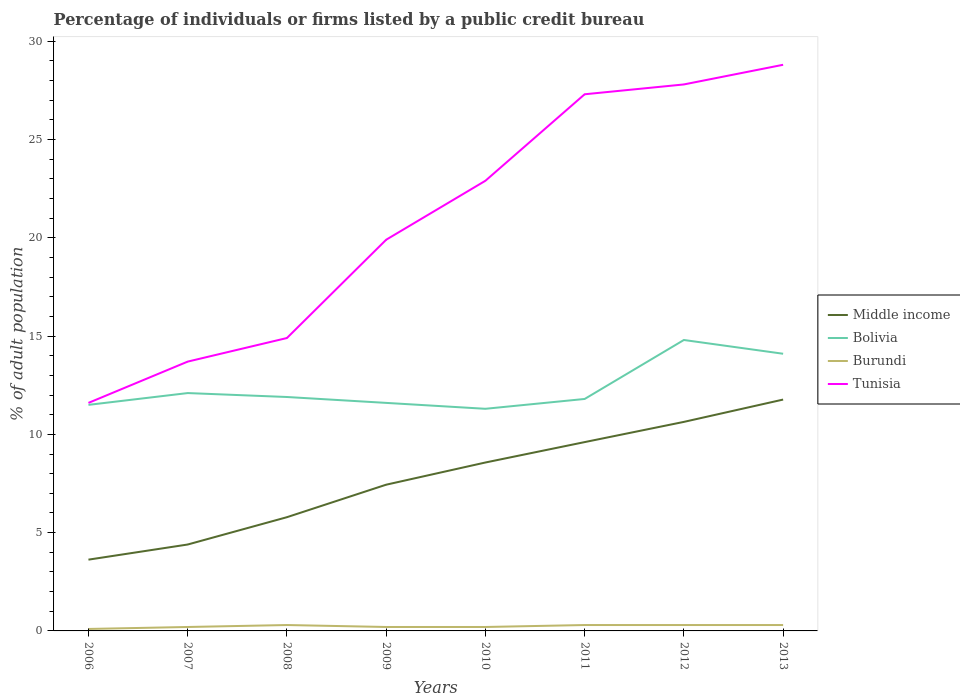How many different coloured lines are there?
Your answer should be very brief. 4. Is the number of lines equal to the number of legend labels?
Your response must be concise. Yes. Across all years, what is the maximum percentage of population listed by a public credit bureau in Middle income?
Offer a very short reply. 3.63. What is the total percentage of population listed by a public credit bureau in Tunisia in the graph?
Your answer should be compact. -16.2. What is the difference between the highest and the second highest percentage of population listed by a public credit bureau in Tunisia?
Your answer should be compact. 17.2. How many lines are there?
Your answer should be compact. 4. What is the difference between two consecutive major ticks on the Y-axis?
Keep it short and to the point. 5. What is the title of the graph?
Your answer should be very brief. Percentage of individuals or firms listed by a public credit bureau. What is the label or title of the X-axis?
Ensure brevity in your answer.  Years. What is the label or title of the Y-axis?
Provide a succinct answer. % of adult population. What is the % of adult population of Middle income in 2006?
Your answer should be very brief. 3.63. What is the % of adult population of Bolivia in 2006?
Give a very brief answer. 11.5. What is the % of adult population in Burundi in 2006?
Offer a terse response. 0.1. What is the % of adult population in Tunisia in 2006?
Your answer should be very brief. 11.6. What is the % of adult population of Middle income in 2007?
Offer a terse response. 4.4. What is the % of adult population in Middle income in 2008?
Make the answer very short. 5.79. What is the % of adult population in Bolivia in 2008?
Provide a short and direct response. 11.9. What is the % of adult population of Middle income in 2009?
Your answer should be compact. 7.44. What is the % of adult population in Bolivia in 2009?
Your answer should be compact. 11.6. What is the % of adult population of Middle income in 2010?
Your response must be concise. 8.57. What is the % of adult population of Tunisia in 2010?
Offer a very short reply. 22.9. What is the % of adult population in Middle income in 2011?
Give a very brief answer. 9.61. What is the % of adult population in Burundi in 2011?
Offer a very short reply. 0.3. What is the % of adult population in Tunisia in 2011?
Provide a short and direct response. 27.3. What is the % of adult population in Middle income in 2012?
Keep it short and to the point. 10.63. What is the % of adult population in Bolivia in 2012?
Ensure brevity in your answer.  14.8. What is the % of adult population of Tunisia in 2012?
Offer a terse response. 27.8. What is the % of adult population of Middle income in 2013?
Keep it short and to the point. 11.77. What is the % of adult population of Bolivia in 2013?
Provide a short and direct response. 14.1. What is the % of adult population in Burundi in 2013?
Make the answer very short. 0.3. What is the % of adult population in Tunisia in 2013?
Offer a very short reply. 28.8. Across all years, what is the maximum % of adult population of Middle income?
Make the answer very short. 11.77. Across all years, what is the maximum % of adult population of Bolivia?
Ensure brevity in your answer.  14.8. Across all years, what is the maximum % of adult population in Burundi?
Your response must be concise. 0.3. Across all years, what is the maximum % of adult population in Tunisia?
Your response must be concise. 28.8. Across all years, what is the minimum % of adult population of Middle income?
Offer a very short reply. 3.63. Across all years, what is the minimum % of adult population in Tunisia?
Give a very brief answer. 11.6. What is the total % of adult population in Middle income in the graph?
Make the answer very short. 61.82. What is the total % of adult population in Bolivia in the graph?
Your response must be concise. 99.1. What is the total % of adult population of Tunisia in the graph?
Your response must be concise. 166.9. What is the difference between the % of adult population in Middle income in 2006 and that in 2007?
Make the answer very short. -0.77. What is the difference between the % of adult population of Bolivia in 2006 and that in 2007?
Your response must be concise. -0.6. What is the difference between the % of adult population in Burundi in 2006 and that in 2007?
Keep it short and to the point. -0.1. What is the difference between the % of adult population in Tunisia in 2006 and that in 2007?
Your answer should be very brief. -2.1. What is the difference between the % of adult population of Middle income in 2006 and that in 2008?
Your answer should be compact. -2.16. What is the difference between the % of adult population in Middle income in 2006 and that in 2009?
Ensure brevity in your answer.  -3.81. What is the difference between the % of adult population in Bolivia in 2006 and that in 2009?
Make the answer very short. -0.1. What is the difference between the % of adult population of Tunisia in 2006 and that in 2009?
Keep it short and to the point. -8.3. What is the difference between the % of adult population in Middle income in 2006 and that in 2010?
Make the answer very short. -4.94. What is the difference between the % of adult population in Bolivia in 2006 and that in 2010?
Offer a very short reply. 0.2. What is the difference between the % of adult population of Burundi in 2006 and that in 2010?
Provide a short and direct response. -0.1. What is the difference between the % of adult population of Middle income in 2006 and that in 2011?
Provide a succinct answer. -5.98. What is the difference between the % of adult population in Bolivia in 2006 and that in 2011?
Offer a terse response. -0.3. What is the difference between the % of adult population in Tunisia in 2006 and that in 2011?
Give a very brief answer. -15.7. What is the difference between the % of adult population of Middle income in 2006 and that in 2012?
Make the answer very short. -7.01. What is the difference between the % of adult population of Bolivia in 2006 and that in 2012?
Provide a short and direct response. -3.3. What is the difference between the % of adult population of Tunisia in 2006 and that in 2012?
Keep it short and to the point. -16.2. What is the difference between the % of adult population in Middle income in 2006 and that in 2013?
Your answer should be very brief. -8.14. What is the difference between the % of adult population in Burundi in 2006 and that in 2013?
Your response must be concise. -0.2. What is the difference between the % of adult population of Tunisia in 2006 and that in 2013?
Your answer should be very brief. -17.2. What is the difference between the % of adult population in Middle income in 2007 and that in 2008?
Your response must be concise. -1.39. What is the difference between the % of adult population of Burundi in 2007 and that in 2008?
Your answer should be compact. -0.1. What is the difference between the % of adult population of Middle income in 2007 and that in 2009?
Offer a terse response. -3.04. What is the difference between the % of adult population in Burundi in 2007 and that in 2009?
Your response must be concise. 0. What is the difference between the % of adult population of Tunisia in 2007 and that in 2009?
Ensure brevity in your answer.  -6.2. What is the difference between the % of adult population of Middle income in 2007 and that in 2010?
Your answer should be compact. -4.17. What is the difference between the % of adult population in Burundi in 2007 and that in 2010?
Your response must be concise. 0. What is the difference between the % of adult population in Tunisia in 2007 and that in 2010?
Give a very brief answer. -9.2. What is the difference between the % of adult population of Middle income in 2007 and that in 2011?
Provide a succinct answer. -5.21. What is the difference between the % of adult population in Burundi in 2007 and that in 2011?
Your response must be concise. -0.1. What is the difference between the % of adult population of Middle income in 2007 and that in 2012?
Ensure brevity in your answer.  -6.24. What is the difference between the % of adult population of Burundi in 2007 and that in 2012?
Your answer should be very brief. -0.1. What is the difference between the % of adult population of Tunisia in 2007 and that in 2012?
Provide a short and direct response. -14.1. What is the difference between the % of adult population in Middle income in 2007 and that in 2013?
Offer a very short reply. -7.37. What is the difference between the % of adult population of Tunisia in 2007 and that in 2013?
Offer a terse response. -15.1. What is the difference between the % of adult population in Middle income in 2008 and that in 2009?
Ensure brevity in your answer.  -1.65. What is the difference between the % of adult population of Middle income in 2008 and that in 2010?
Give a very brief answer. -2.78. What is the difference between the % of adult population in Bolivia in 2008 and that in 2010?
Your response must be concise. 0.6. What is the difference between the % of adult population in Burundi in 2008 and that in 2010?
Keep it short and to the point. 0.1. What is the difference between the % of adult population of Middle income in 2008 and that in 2011?
Offer a terse response. -3.82. What is the difference between the % of adult population of Burundi in 2008 and that in 2011?
Ensure brevity in your answer.  0. What is the difference between the % of adult population of Tunisia in 2008 and that in 2011?
Your answer should be very brief. -12.4. What is the difference between the % of adult population in Middle income in 2008 and that in 2012?
Your answer should be compact. -4.85. What is the difference between the % of adult population in Burundi in 2008 and that in 2012?
Your answer should be compact. 0. What is the difference between the % of adult population in Middle income in 2008 and that in 2013?
Your answer should be compact. -5.98. What is the difference between the % of adult population of Tunisia in 2008 and that in 2013?
Offer a very short reply. -13.9. What is the difference between the % of adult population in Middle income in 2009 and that in 2010?
Keep it short and to the point. -1.13. What is the difference between the % of adult population in Tunisia in 2009 and that in 2010?
Provide a succinct answer. -3. What is the difference between the % of adult population in Middle income in 2009 and that in 2011?
Make the answer very short. -2.17. What is the difference between the % of adult population of Tunisia in 2009 and that in 2011?
Give a very brief answer. -7.4. What is the difference between the % of adult population in Middle income in 2009 and that in 2012?
Your response must be concise. -3.19. What is the difference between the % of adult population in Middle income in 2009 and that in 2013?
Your answer should be very brief. -4.33. What is the difference between the % of adult population of Middle income in 2010 and that in 2011?
Offer a very short reply. -1.04. What is the difference between the % of adult population of Tunisia in 2010 and that in 2011?
Keep it short and to the point. -4.4. What is the difference between the % of adult population of Middle income in 2010 and that in 2012?
Your response must be concise. -2.07. What is the difference between the % of adult population of Bolivia in 2010 and that in 2012?
Your answer should be very brief. -3.5. What is the difference between the % of adult population of Burundi in 2010 and that in 2012?
Your response must be concise. -0.1. What is the difference between the % of adult population in Tunisia in 2010 and that in 2012?
Your answer should be compact. -4.9. What is the difference between the % of adult population in Middle income in 2010 and that in 2013?
Offer a very short reply. -3.2. What is the difference between the % of adult population of Bolivia in 2010 and that in 2013?
Provide a succinct answer. -2.8. What is the difference between the % of adult population of Middle income in 2011 and that in 2012?
Give a very brief answer. -1.03. What is the difference between the % of adult population of Burundi in 2011 and that in 2012?
Offer a very short reply. 0. What is the difference between the % of adult population in Tunisia in 2011 and that in 2012?
Your answer should be compact. -0.5. What is the difference between the % of adult population in Middle income in 2011 and that in 2013?
Make the answer very short. -2.16. What is the difference between the % of adult population in Bolivia in 2011 and that in 2013?
Offer a very short reply. -2.3. What is the difference between the % of adult population of Burundi in 2011 and that in 2013?
Provide a short and direct response. 0. What is the difference between the % of adult population of Tunisia in 2011 and that in 2013?
Offer a very short reply. -1.5. What is the difference between the % of adult population of Middle income in 2012 and that in 2013?
Your response must be concise. -1.14. What is the difference between the % of adult population in Tunisia in 2012 and that in 2013?
Your answer should be compact. -1. What is the difference between the % of adult population of Middle income in 2006 and the % of adult population of Bolivia in 2007?
Make the answer very short. -8.47. What is the difference between the % of adult population in Middle income in 2006 and the % of adult population in Burundi in 2007?
Give a very brief answer. 3.43. What is the difference between the % of adult population of Middle income in 2006 and the % of adult population of Tunisia in 2007?
Give a very brief answer. -10.07. What is the difference between the % of adult population of Bolivia in 2006 and the % of adult population of Tunisia in 2007?
Provide a short and direct response. -2.2. What is the difference between the % of adult population in Burundi in 2006 and the % of adult population in Tunisia in 2007?
Make the answer very short. -13.6. What is the difference between the % of adult population in Middle income in 2006 and the % of adult population in Bolivia in 2008?
Offer a terse response. -8.27. What is the difference between the % of adult population in Middle income in 2006 and the % of adult population in Burundi in 2008?
Your answer should be compact. 3.33. What is the difference between the % of adult population in Middle income in 2006 and the % of adult population in Tunisia in 2008?
Provide a succinct answer. -11.27. What is the difference between the % of adult population in Bolivia in 2006 and the % of adult population in Burundi in 2008?
Your answer should be very brief. 11.2. What is the difference between the % of adult population of Bolivia in 2006 and the % of adult population of Tunisia in 2008?
Give a very brief answer. -3.4. What is the difference between the % of adult population in Burundi in 2006 and the % of adult population in Tunisia in 2008?
Keep it short and to the point. -14.8. What is the difference between the % of adult population of Middle income in 2006 and the % of adult population of Bolivia in 2009?
Your answer should be compact. -7.97. What is the difference between the % of adult population in Middle income in 2006 and the % of adult population in Burundi in 2009?
Ensure brevity in your answer.  3.43. What is the difference between the % of adult population of Middle income in 2006 and the % of adult population of Tunisia in 2009?
Provide a succinct answer. -16.27. What is the difference between the % of adult population in Bolivia in 2006 and the % of adult population in Tunisia in 2009?
Provide a succinct answer. -8.4. What is the difference between the % of adult population in Burundi in 2006 and the % of adult population in Tunisia in 2009?
Offer a terse response. -19.8. What is the difference between the % of adult population in Middle income in 2006 and the % of adult population in Bolivia in 2010?
Make the answer very short. -7.67. What is the difference between the % of adult population of Middle income in 2006 and the % of adult population of Burundi in 2010?
Your answer should be compact. 3.43. What is the difference between the % of adult population of Middle income in 2006 and the % of adult population of Tunisia in 2010?
Ensure brevity in your answer.  -19.27. What is the difference between the % of adult population of Bolivia in 2006 and the % of adult population of Tunisia in 2010?
Make the answer very short. -11.4. What is the difference between the % of adult population of Burundi in 2006 and the % of adult population of Tunisia in 2010?
Give a very brief answer. -22.8. What is the difference between the % of adult population of Middle income in 2006 and the % of adult population of Bolivia in 2011?
Make the answer very short. -8.17. What is the difference between the % of adult population in Middle income in 2006 and the % of adult population in Burundi in 2011?
Offer a very short reply. 3.33. What is the difference between the % of adult population in Middle income in 2006 and the % of adult population in Tunisia in 2011?
Your response must be concise. -23.67. What is the difference between the % of adult population in Bolivia in 2006 and the % of adult population in Burundi in 2011?
Make the answer very short. 11.2. What is the difference between the % of adult population of Bolivia in 2006 and the % of adult population of Tunisia in 2011?
Your answer should be compact. -15.8. What is the difference between the % of adult population of Burundi in 2006 and the % of adult population of Tunisia in 2011?
Your answer should be compact. -27.2. What is the difference between the % of adult population of Middle income in 2006 and the % of adult population of Bolivia in 2012?
Keep it short and to the point. -11.17. What is the difference between the % of adult population of Middle income in 2006 and the % of adult population of Burundi in 2012?
Give a very brief answer. 3.33. What is the difference between the % of adult population in Middle income in 2006 and the % of adult population in Tunisia in 2012?
Make the answer very short. -24.17. What is the difference between the % of adult population in Bolivia in 2006 and the % of adult population in Tunisia in 2012?
Your response must be concise. -16.3. What is the difference between the % of adult population of Burundi in 2006 and the % of adult population of Tunisia in 2012?
Provide a short and direct response. -27.7. What is the difference between the % of adult population in Middle income in 2006 and the % of adult population in Bolivia in 2013?
Provide a short and direct response. -10.47. What is the difference between the % of adult population in Middle income in 2006 and the % of adult population in Burundi in 2013?
Offer a terse response. 3.33. What is the difference between the % of adult population in Middle income in 2006 and the % of adult population in Tunisia in 2013?
Give a very brief answer. -25.17. What is the difference between the % of adult population in Bolivia in 2006 and the % of adult population in Burundi in 2013?
Offer a very short reply. 11.2. What is the difference between the % of adult population in Bolivia in 2006 and the % of adult population in Tunisia in 2013?
Make the answer very short. -17.3. What is the difference between the % of adult population in Burundi in 2006 and the % of adult population in Tunisia in 2013?
Ensure brevity in your answer.  -28.7. What is the difference between the % of adult population of Middle income in 2007 and the % of adult population of Bolivia in 2008?
Your answer should be very brief. -7.5. What is the difference between the % of adult population in Middle income in 2007 and the % of adult population in Burundi in 2008?
Provide a succinct answer. 4.1. What is the difference between the % of adult population in Middle income in 2007 and the % of adult population in Tunisia in 2008?
Keep it short and to the point. -10.5. What is the difference between the % of adult population in Bolivia in 2007 and the % of adult population in Burundi in 2008?
Provide a short and direct response. 11.8. What is the difference between the % of adult population in Bolivia in 2007 and the % of adult population in Tunisia in 2008?
Provide a short and direct response. -2.8. What is the difference between the % of adult population of Burundi in 2007 and the % of adult population of Tunisia in 2008?
Offer a very short reply. -14.7. What is the difference between the % of adult population of Middle income in 2007 and the % of adult population of Bolivia in 2009?
Keep it short and to the point. -7.2. What is the difference between the % of adult population in Middle income in 2007 and the % of adult population in Burundi in 2009?
Your response must be concise. 4.2. What is the difference between the % of adult population in Middle income in 2007 and the % of adult population in Tunisia in 2009?
Ensure brevity in your answer.  -15.5. What is the difference between the % of adult population of Bolivia in 2007 and the % of adult population of Burundi in 2009?
Make the answer very short. 11.9. What is the difference between the % of adult population in Burundi in 2007 and the % of adult population in Tunisia in 2009?
Make the answer very short. -19.7. What is the difference between the % of adult population of Middle income in 2007 and the % of adult population of Bolivia in 2010?
Give a very brief answer. -6.9. What is the difference between the % of adult population in Middle income in 2007 and the % of adult population in Burundi in 2010?
Provide a succinct answer. 4.2. What is the difference between the % of adult population in Middle income in 2007 and the % of adult population in Tunisia in 2010?
Make the answer very short. -18.5. What is the difference between the % of adult population in Bolivia in 2007 and the % of adult population in Tunisia in 2010?
Offer a very short reply. -10.8. What is the difference between the % of adult population of Burundi in 2007 and the % of adult population of Tunisia in 2010?
Keep it short and to the point. -22.7. What is the difference between the % of adult population in Middle income in 2007 and the % of adult population in Bolivia in 2011?
Your answer should be compact. -7.4. What is the difference between the % of adult population of Middle income in 2007 and the % of adult population of Burundi in 2011?
Your answer should be very brief. 4.1. What is the difference between the % of adult population of Middle income in 2007 and the % of adult population of Tunisia in 2011?
Your response must be concise. -22.9. What is the difference between the % of adult population of Bolivia in 2007 and the % of adult population of Burundi in 2011?
Your response must be concise. 11.8. What is the difference between the % of adult population in Bolivia in 2007 and the % of adult population in Tunisia in 2011?
Provide a succinct answer. -15.2. What is the difference between the % of adult population of Burundi in 2007 and the % of adult population of Tunisia in 2011?
Offer a very short reply. -27.1. What is the difference between the % of adult population of Middle income in 2007 and the % of adult population of Bolivia in 2012?
Your answer should be very brief. -10.4. What is the difference between the % of adult population in Middle income in 2007 and the % of adult population in Burundi in 2012?
Ensure brevity in your answer.  4.1. What is the difference between the % of adult population of Middle income in 2007 and the % of adult population of Tunisia in 2012?
Make the answer very short. -23.4. What is the difference between the % of adult population of Bolivia in 2007 and the % of adult population of Burundi in 2012?
Your answer should be compact. 11.8. What is the difference between the % of adult population of Bolivia in 2007 and the % of adult population of Tunisia in 2012?
Offer a very short reply. -15.7. What is the difference between the % of adult population in Burundi in 2007 and the % of adult population in Tunisia in 2012?
Provide a short and direct response. -27.6. What is the difference between the % of adult population in Middle income in 2007 and the % of adult population in Bolivia in 2013?
Offer a terse response. -9.7. What is the difference between the % of adult population in Middle income in 2007 and the % of adult population in Burundi in 2013?
Provide a succinct answer. 4.1. What is the difference between the % of adult population in Middle income in 2007 and the % of adult population in Tunisia in 2013?
Keep it short and to the point. -24.4. What is the difference between the % of adult population of Bolivia in 2007 and the % of adult population of Burundi in 2013?
Your answer should be compact. 11.8. What is the difference between the % of adult population of Bolivia in 2007 and the % of adult population of Tunisia in 2013?
Keep it short and to the point. -16.7. What is the difference between the % of adult population of Burundi in 2007 and the % of adult population of Tunisia in 2013?
Give a very brief answer. -28.6. What is the difference between the % of adult population in Middle income in 2008 and the % of adult population in Bolivia in 2009?
Make the answer very short. -5.81. What is the difference between the % of adult population of Middle income in 2008 and the % of adult population of Burundi in 2009?
Offer a terse response. 5.59. What is the difference between the % of adult population in Middle income in 2008 and the % of adult population in Tunisia in 2009?
Ensure brevity in your answer.  -14.11. What is the difference between the % of adult population of Burundi in 2008 and the % of adult population of Tunisia in 2009?
Your answer should be very brief. -19.6. What is the difference between the % of adult population in Middle income in 2008 and the % of adult population in Bolivia in 2010?
Provide a succinct answer. -5.51. What is the difference between the % of adult population in Middle income in 2008 and the % of adult population in Burundi in 2010?
Ensure brevity in your answer.  5.59. What is the difference between the % of adult population of Middle income in 2008 and the % of adult population of Tunisia in 2010?
Your answer should be very brief. -17.11. What is the difference between the % of adult population in Bolivia in 2008 and the % of adult population in Burundi in 2010?
Provide a short and direct response. 11.7. What is the difference between the % of adult population of Burundi in 2008 and the % of adult population of Tunisia in 2010?
Offer a terse response. -22.6. What is the difference between the % of adult population in Middle income in 2008 and the % of adult population in Bolivia in 2011?
Your response must be concise. -6.01. What is the difference between the % of adult population in Middle income in 2008 and the % of adult population in Burundi in 2011?
Keep it short and to the point. 5.49. What is the difference between the % of adult population of Middle income in 2008 and the % of adult population of Tunisia in 2011?
Keep it short and to the point. -21.51. What is the difference between the % of adult population of Bolivia in 2008 and the % of adult population of Tunisia in 2011?
Provide a succinct answer. -15.4. What is the difference between the % of adult population of Burundi in 2008 and the % of adult population of Tunisia in 2011?
Give a very brief answer. -27. What is the difference between the % of adult population in Middle income in 2008 and the % of adult population in Bolivia in 2012?
Ensure brevity in your answer.  -9.01. What is the difference between the % of adult population of Middle income in 2008 and the % of adult population of Burundi in 2012?
Provide a succinct answer. 5.49. What is the difference between the % of adult population of Middle income in 2008 and the % of adult population of Tunisia in 2012?
Offer a terse response. -22.01. What is the difference between the % of adult population of Bolivia in 2008 and the % of adult population of Burundi in 2012?
Provide a succinct answer. 11.6. What is the difference between the % of adult population of Bolivia in 2008 and the % of adult population of Tunisia in 2012?
Your response must be concise. -15.9. What is the difference between the % of adult population in Burundi in 2008 and the % of adult population in Tunisia in 2012?
Offer a very short reply. -27.5. What is the difference between the % of adult population in Middle income in 2008 and the % of adult population in Bolivia in 2013?
Provide a short and direct response. -8.31. What is the difference between the % of adult population of Middle income in 2008 and the % of adult population of Burundi in 2013?
Provide a succinct answer. 5.49. What is the difference between the % of adult population in Middle income in 2008 and the % of adult population in Tunisia in 2013?
Provide a succinct answer. -23.01. What is the difference between the % of adult population in Bolivia in 2008 and the % of adult population in Burundi in 2013?
Make the answer very short. 11.6. What is the difference between the % of adult population in Bolivia in 2008 and the % of adult population in Tunisia in 2013?
Provide a short and direct response. -16.9. What is the difference between the % of adult population in Burundi in 2008 and the % of adult population in Tunisia in 2013?
Offer a terse response. -28.5. What is the difference between the % of adult population of Middle income in 2009 and the % of adult population of Bolivia in 2010?
Give a very brief answer. -3.86. What is the difference between the % of adult population of Middle income in 2009 and the % of adult population of Burundi in 2010?
Make the answer very short. 7.24. What is the difference between the % of adult population of Middle income in 2009 and the % of adult population of Tunisia in 2010?
Ensure brevity in your answer.  -15.46. What is the difference between the % of adult population of Burundi in 2009 and the % of adult population of Tunisia in 2010?
Offer a very short reply. -22.7. What is the difference between the % of adult population of Middle income in 2009 and the % of adult population of Bolivia in 2011?
Provide a succinct answer. -4.36. What is the difference between the % of adult population of Middle income in 2009 and the % of adult population of Burundi in 2011?
Ensure brevity in your answer.  7.14. What is the difference between the % of adult population in Middle income in 2009 and the % of adult population in Tunisia in 2011?
Make the answer very short. -19.86. What is the difference between the % of adult population of Bolivia in 2009 and the % of adult population of Burundi in 2011?
Provide a succinct answer. 11.3. What is the difference between the % of adult population in Bolivia in 2009 and the % of adult population in Tunisia in 2011?
Give a very brief answer. -15.7. What is the difference between the % of adult population in Burundi in 2009 and the % of adult population in Tunisia in 2011?
Offer a terse response. -27.1. What is the difference between the % of adult population in Middle income in 2009 and the % of adult population in Bolivia in 2012?
Provide a short and direct response. -7.36. What is the difference between the % of adult population in Middle income in 2009 and the % of adult population in Burundi in 2012?
Give a very brief answer. 7.14. What is the difference between the % of adult population in Middle income in 2009 and the % of adult population in Tunisia in 2012?
Keep it short and to the point. -20.36. What is the difference between the % of adult population of Bolivia in 2009 and the % of adult population of Burundi in 2012?
Keep it short and to the point. 11.3. What is the difference between the % of adult population of Bolivia in 2009 and the % of adult population of Tunisia in 2012?
Make the answer very short. -16.2. What is the difference between the % of adult population in Burundi in 2009 and the % of adult population in Tunisia in 2012?
Your answer should be very brief. -27.6. What is the difference between the % of adult population of Middle income in 2009 and the % of adult population of Bolivia in 2013?
Give a very brief answer. -6.66. What is the difference between the % of adult population of Middle income in 2009 and the % of adult population of Burundi in 2013?
Offer a very short reply. 7.14. What is the difference between the % of adult population in Middle income in 2009 and the % of adult population in Tunisia in 2013?
Your answer should be compact. -21.36. What is the difference between the % of adult population in Bolivia in 2009 and the % of adult population in Tunisia in 2013?
Keep it short and to the point. -17.2. What is the difference between the % of adult population of Burundi in 2009 and the % of adult population of Tunisia in 2013?
Offer a terse response. -28.6. What is the difference between the % of adult population of Middle income in 2010 and the % of adult population of Bolivia in 2011?
Ensure brevity in your answer.  -3.23. What is the difference between the % of adult population of Middle income in 2010 and the % of adult population of Burundi in 2011?
Offer a very short reply. 8.27. What is the difference between the % of adult population of Middle income in 2010 and the % of adult population of Tunisia in 2011?
Provide a succinct answer. -18.73. What is the difference between the % of adult population of Bolivia in 2010 and the % of adult population of Tunisia in 2011?
Offer a very short reply. -16. What is the difference between the % of adult population of Burundi in 2010 and the % of adult population of Tunisia in 2011?
Your answer should be compact. -27.1. What is the difference between the % of adult population of Middle income in 2010 and the % of adult population of Bolivia in 2012?
Provide a short and direct response. -6.23. What is the difference between the % of adult population of Middle income in 2010 and the % of adult population of Burundi in 2012?
Ensure brevity in your answer.  8.27. What is the difference between the % of adult population in Middle income in 2010 and the % of adult population in Tunisia in 2012?
Ensure brevity in your answer.  -19.23. What is the difference between the % of adult population of Bolivia in 2010 and the % of adult population of Burundi in 2012?
Offer a very short reply. 11. What is the difference between the % of adult population of Bolivia in 2010 and the % of adult population of Tunisia in 2012?
Offer a terse response. -16.5. What is the difference between the % of adult population in Burundi in 2010 and the % of adult population in Tunisia in 2012?
Make the answer very short. -27.6. What is the difference between the % of adult population of Middle income in 2010 and the % of adult population of Bolivia in 2013?
Ensure brevity in your answer.  -5.53. What is the difference between the % of adult population of Middle income in 2010 and the % of adult population of Burundi in 2013?
Offer a very short reply. 8.27. What is the difference between the % of adult population in Middle income in 2010 and the % of adult population in Tunisia in 2013?
Give a very brief answer. -20.23. What is the difference between the % of adult population in Bolivia in 2010 and the % of adult population in Tunisia in 2013?
Your answer should be very brief. -17.5. What is the difference between the % of adult population of Burundi in 2010 and the % of adult population of Tunisia in 2013?
Offer a terse response. -28.6. What is the difference between the % of adult population in Middle income in 2011 and the % of adult population in Bolivia in 2012?
Give a very brief answer. -5.19. What is the difference between the % of adult population in Middle income in 2011 and the % of adult population in Burundi in 2012?
Offer a terse response. 9.31. What is the difference between the % of adult population of Middle income in 2011 and the % of adult population of Tunisia in 2012?
Give a very brief answer. -18.19. What is the difference between the % of adult population in Bolivia in 2011 and the % of adult population in Tunisia in 2012?
Make the answer very short. -16. What is the difference between the % of adult population in Burundi in 2011 and the % of adult population in Tunisia in 2012?
Provide a succinct answer. -27.5. What is the difference between the % of adult population of Middle income in 2011 and the % of adult population of Bolivia in 2013?
Your answer should be very brief. -4.49. What is the difference between the % of adult population in Middle income in 2011 and the % of adult population in Burundi in 2013?
Ensure brevity in your answer.  9.31. What is the difference between the % of adult population in Middle income in 2011 and the % of adult population in Tunisia in 2013?
Ensure brevity in your answer.  -19.19. What is the difference between the % of adult population of Burundi in 2011 and the % of adult population of Tunisia in 2013?
Your response must be concise. -28.5. What is the difference between the % of adult population in Middle income in 2012 and the % of adult population in Bolivia in 2013?
Offer a terse response. -3.47. What is the difference between the % of adult population of Middle income in 2012 and the % of adult population of Burundi in 2013?
Ensure brevity in your answer.  10.33. What is the difference between the % of adult population of Middle income in 2012 and the % of adult population of Tunisia in 2013?
Give a very brief answer. -18.17. What is the difference between the % of adult population in Bolivia in 2012 and the % of adult population in Burundi in 2013?
Your response must be concise. 14.5. What is the difference between the % of adult population of Bolivia in 2012 and the % of adult population of Tunisia in 2013?
Your answer should be compact. -14. What is the difference between the % of adult population of Burundi in 2012 and the % of adult population of Tunisia in 2013?
Give a very brief answer. -28.5. What is the average % of adult population in Middle income per year?
Give a very brief answer. 7.73. What is the average % of adult population of Bolivia per year?
Give a very brief answer. 12.39. What is the average % of adult population of Burundi per year?
Offer a terse response. 0.24. What is the average % of adult population in Tunisia per year?
Your answer should be compact. 20.86. In the year 2006, what is the difference between the % of adult population of Middle income and % of adult population of Bolivia?
Offer a terse response. -7.87. In the year 2006, what is the difference between the % of adult population of Middle income and % of adult population of Burundi?
Offer a terse response. 3.53. In the year 2006, what is the difference between the % of adult population in Middle income and % of adult population in Tunisia?
Ensure brevity in your answer.  -7.97. In the year 2006, what is the difference between the % of adult population of Bolivia and % of adult population of Burundi?
Offer a very short reply. 11.4. In the year 2006, what is the difference between the % of adult population in Bolivia and % of adult population in Tunisia?
Offer a terse response. -0.1. In the year 2007, what is the difference between the % of adult population in Middle income and % of adult population in Bolivia?
Provide a short and direct response. -7.7. In the year 2007, what is the difference between the % of adult population of Middle income and % of adult population of Burundi?
Keep it short and to the point. 4.2. In the year 2007, what is the difference between the % of adult population in Middle income and % of adult population in Tunisia?
Ensure brevity in your answer.  -9.3. In the year 2007, what is the difference between the % of adult population in Bolivia and % of adult population in Burundi?
Your answer should be very brief. 11.9. In the year 2007, what is the difference between the % of adult population of Bolivia and % of adult population of Tunisia?
Provide a succinct answer. -1.6. In the year 2007, what is the difference between the % of adult population of Burundi and % of adult population of Tunisia?
Your response must be concise. -13.5. In the year 2008, what is the difference between the % of adult population of Middle income and % of adult population of Bolivia?
Offer a terse response. -6.11. In the year 2008, what is the difference between the % of adult population of Middle income and % of adult population of Burundi?
Keep it short and to the point. 5.49. In the year 2008, what is the difference between the % of adult population in Middle income and % of adult population in Tunisia?
Make the answer very short. -9.11. In the year 2008, what is the difference between the % of adult population in Bolivia and % of adult population in Burundi?
Ensure brevity in your answer.  11.6. In the year 2008, what is the difference between the % of adult population in Burundi and % of adult population in Tunisia?
Offer a very short reply. -14.6. In the year 2009, what is the difference between the % of adult population of Middle income and % of adult population of Bolivia?
Provide a succinct answer. -4.16. In the year 2009, what is the difference between the % of adult population in Middle income and % of adult population in Burundi?
Give a very brief answer. 7.24. In the year 2009, what is the difference between the % of adult population in Middle income and % of adult population in Tunisia?
Offer a terse response. -12.46. In the year 2009, what is the difference between the % of adult population in Bolivia and % of adult population in Tunisia?
Provide a succinct answer. -8.3. In the year 2009, what is the difference between the % of adult population in Burundi and % of adult population in Tunisia?
Your answer should be very brief. -19.7. In the year 2010, what is the difference between the % of adult population in Middle income and % of adult population in Bolivia?
Keep it short and to the point. -2.73. In the year 2010, what is the difference between the % of adult population in Middle income and % of adult population in Burundi?
Your answer should be compact. 8.37. In the year 2010, what is the difference between the % of adult population of Middle income and % of adult population of Tunisia?
Your response must be concise. -14.33. In the year 2010, what is the difference between the % of adult population of Bolivia and % of adult population of Burundi?
Ensure brevity in your answer.  11.1. In the year 2010, what is the difference between the % of adult population in Bolivia and % of adult population in Tunisia?
Your answer should be very brief. -11.6. In the year 2010, what is the difference between the % of adult population in Burundi and % of adult population in Tunisia?
Make the answer very short. -22.7. In the year 2011, what is the difference between the % of adult population of Middle income and % of adult population of Bolivia?
Offer a terse response. -2.19. In the year 2011, what is the difference between the % of adult population in Middle income and % of adult population in Burundi?
Provide a succinct answer. 9.31. In the year 2011, what is the difference between the % of adult population of Middle income and % of adult population of Tunisia?
Your response must be concise. -17.69. In the year 2011, what is the difference between the % of adult population in Bolivia and % of adult population in Tunisia?
Your answer should be very brief. -15.5. In the year 2011, what is the difference between the % of adult population of Burundi and % of adult population of Tunisia?
Your response must be concise. -27. In the year 2012, what is the difference between the % of adult population in Middle income and % of adult population in Bolivia?
Give a very brief answer. -4.17. In the year 2012, what is the difference between the % of adult population in Middle income and % of adult population in Burundi?
Your answer should be compact. 10.33. In the year 2012, what is the difference between the % of adult population of Middle income and % of adult population of Tunisia?
Provide a succinct answer. -17.17. In the year 2012, what is the difference between the % of adult population of Bolivia and % of adult population of Burundi?
Offer a terse response. 14.5. In the year 2012, what is the difference between the % of adult population in Bolivia and % of adult population in Tunisia?
Your response must be concise. -13. In the year 2012, what is the difference between the % of adult population of Burundi and % of adult population of Tunisia?
Your response must be concise. -27.5. In the year 2013, what is the difference between the % of adult population of Middle income and % of adult population of Bolivia?
Your answer should be very brief. -2.33. In the year 2013, what is the difference between the % of adult population of Middle income and % of adult population of Burundi?
Give a very brief answer. 11.47. In the year 2013, what is the difference between the % of adult population of Middle income and % of adult population of Tunisia?
Provide a short and direct response. -17.03. In the year 2013, what is the difference between the % of adult population of Bolivia and % of adult population of Burundi?
Ensure brevity in your answer.  13.8. In the year 2013, what is the difference between the % of adult population in Bolivia and % of adult population in Tunisia?
Keep it short and to the point. -14.7. In the year 2013, what is the difference between the % of adult population in Burundi and % of adult population in Tunisia?
Your response must be concise. -28.5. What is the ratio of the % of adult population in Middle income in 2006 to that in 2007?
Make the answer very short. 0.82. What is the ratio of the % of adult population of Bolivia in 2006 to that in 2007?
Your response must be concise. 0.95. What is the ratio of the % of adult population in Tunisia in 2006 to that in 2007?
Provide a succinct answer. 0.85. What is the ratio of the % of adult population of Middle income in 2006 to that in 2008?
Your response must be concise. 0.63. What is the ratio of the % of adult population of Bolivia in 2006 to that in 2008?
Provide a short and direct response. 0.97. What is the ratio of the % of adult population in Burundi in 2006 to that in 2008?
Give a very brief answer. 0.33. What is the ratio of the % of adult population in Tunisia in 2006 to that in 2008?
Offer a terse response. 0.78. What is the ratio of the % of adult population of Middle income in 2006 to that in 2009?
Ensure brevity in your answer.  0.49. What is the ratio of the % of adult population of Burundi in 2006 to that in 2009?
Your response must be concise. 0.5. What is the ratio of the % of adult population of Tunisia in 2006 to that in 2009?
Your answer should be compact. 0.58. What is the ratio of the % of adult population of Middle income in 2006 to that in 2010?
Keep it short and to the point. 0.42. What is the ratio of the % of adult population in Bolivia in 2006 to that in 2010?
Make the answer very short. 1.02. What is the ratio of the % of adult population of Tunisia in 2006 to that in 2010?
Keep it short and to the point. 0.51. What is the ratio of the % of adult population in Middle income in 2006 to that in 2011?
Provide a succinct answer. 0.38. What is the ratio of the % of adult population of Bolivia in 2006 to that in 2011?
Provide a succinct answer. 0.97. What is the ratio of the % of adult population in Tunisia in 2006 to that in 2011?
Offer a very short reply. 0.42. What is the ratio of the % of adult population in Middle income in 2006 to that in 2012?
Provide a succinct answer. 0.34. What is the ratio of the % of adult population in Bolivia in 2006 to that in 2012?
Your answer should be very brief. 0.78. What is the ratio of the % of adult population in Burundi in 2006 to that in 2012?
Make the answer very short. 0.33. What is the ratio of the % of adult population of Tunisia in 2006 to that in 2012?
Offer a very short reply. 0.42. What is the ratio of the % of adult population of Middle income in 2006 to that in 2013?
Your answer should be very brief. 0.31. What is the ratio of the % of adult population of Bolivia in 2006 to that in 2013?
Provide a short and direct response. 0.82. What is the ratio of the % of adult population of Burundi in 2006 to that in 2013?
Provide a succinct answer. 0.33. What is the ratio of the % of adult population in Tunisia in 2006 to that in 2013?
Offer a very short reply. 0.4. What is the ratio of the % of adult population of Middle income in 2007 to that in 2008?
Give a very brief answer. 0.76. What is the ratio of the % of adult population in Bolivia in 2007 to that in 2008?
Keep it short and to the point. 1.02. What is the ratio of the % of adult population in Tunisia in 2007 to that in 2008?
Provide a succinct answer. 0.92. What is the ratio of the % of adult population of Middle income in 2007 to that in 2009?
Your answer should be very brief. 0.59. What is the ratio of the % of adult population in Bolivia in 2007 to that in 2009?
Give a very brief answer. 1.04. What is the ratio of the % of adult population of Tunisia in 2007 to that in 2009?
Your answer should be very brief. 0.69. What is the ratio of the % of adult population of Middle income in 2007 to that in 2010?
Your response must be concise. 0.51. What is the ratio of the % of adult population in Bolivia in 2007 to that in 2010?
Your answer should be very brief. 1.07. What is the ratio of the % of adult population of Burundi in 2007 to that in 2010?
Your response must be concise. 1. What is the ratio of the % of adult population in Tunisia in 2007 to that in 2010?
Provide a short and direct response. 0.6. What is the ratio of the % of adult population in Middle income in 2007 to that in 2011?
Your answer should be very brief. 0.46. What is the ratio of the % of adult population in Bolivia in 2007 to that in 2011?
Make the answer very short. 1.03. What is the ratio of the % of adult population in Tunisia in 2007 to that in 2011?
Keep it short and to the point. 0.5. What is the ratio of the % of adult population of Middle income in 2007 to that in 2012?
Offer a very short reply. 0.41. What is the ratio of the % of adult population in Bolivia in 2007 to that in 2012?
Keep it short and to the point. 0.82. What is the ratio of the % of adult population of Burundi in 2007 to that in 2012?
Keep it short and to the point. 0.67. What is the ratio of the % of adult population of Tunisia in 2007 to that in 2012?
Your answer should be compact. 0.49. What is the ratio of the % of adult population of Middle income in 2007 to that in 2013?
Provide a succinct answer. 0.37. What is the ratio of the % of adult population of Bolivia in 2007 to that in 2013?
Ensure brevity in your answer.  0.86. What is the ratio of the % of adult population in Burundi in 2007 to that in 2013?
Offer a very short reply. 0.67. What is the ratio of the % of adult population of Tunisia in 2007 to that in 2013?
Provide a succinct answer. 0.48. What is the ratio of the % of adult population of Middle income in 2008 to that in 2009?
Offer a very short reply. 0.78. What is the ratio of the % of adult population of Bolivia in 2008 to that in 2009?
Your answer should be very brief. 1.03. What is the ratio of the % of adult population in Tunisia in 2008 to that in 2009?
Make the answer very short. 0.75. What is the ratio of the % of adult population in Middle income in 2008 to that in 2010?
Provide a succinct answer. 0.68. What is the ratio of the % of adult population in Bolivia in 2008 to that in 2010?
Offer a terse response. 1.05. What is the ratio of the % of adult population of Tunisia in 2008 to that in 2010?
Ensure brevity in your answer.  0.65. What is the ratio of the % of adult population of Middle income in 2008 to that in 2011?
Keep it short and to the point. 0.6. What is the ratio of the % of adult population in Bolivia in 2008 to that in 2011?
Your answer should be very brief. 1.01. What is the ratio of the % of adult population in Tunisia in 2008 to that in 2011?
Your response must be concise. 0.55. What is the ratio of the % of adult population in Middle income in 2008 to that in 2012?
Ensure brevity in your answer.  0.54. What is the ratio of the % of adult population of Bolivia in 2008 to that in 2012?
Your response must be concise. 0.8. What is the ratio of the % of adult population of Burundi in 2008 to that in 2012?
Provide a short and direct response. 1. What is the ratio of the % of adult population of Tunisia in 2008 to that in 2012?
Keep it short and to the point. 0.54. What is the ratio of the % of adult population in Middle income in 2008 to that in 2013?
Make the answer very short. 0.49. What is the ratio of the % of adult population in Bolivia in 2008 to that in 2013?
Your response must be concise. 0.84. What is the ratio of the % of adult population in Burundi in 2008 to that in 2013?
Offer a very short reply. 1. What is the ratio of the % of adult population in Tunisia in 2008 to that in 2013?
Ensure brevity in your answer.  0.52. What is the ratio of the % of adult population of Middle income in 2009 to that in 2010?
Your answer should be very brief. 0.87. What is the ratio of the % of adult population in Bolivia in 2009 to that in 2010?
Give a very brief answer. 1.03. What is the ratio of the % of adult population in Burundi in 2009 to that in 2010?
Your response must be concise. 1. What is the ratio of the % of adult population in Tunisia in 2009 to that in 2010?
Offer a terse response. 0.87. What is the ratio of the % of adult population of Middle income in 2009 to that in 2011?
Your answer should be very brief. 0.77. What is the ratio of the % of adult population in Bolivia in 2009 to that in 2011?
Provide a succinct answer. 0.98. What is the ratio of the % of adult population in Tunisia in 2009 to that in 2011?
Provide a short and direct response. 0.73. What is the ratio of the % of adult population of Middle income in 2009 to that in 2012?
Give a very brief answer. 0.7. What is the ratio of the % of adult population in Bolivia in 2009 to that in 2012?
Your answer should be very brief. 0.78. What is the ratio of the % of adult population of Tunisia in 2009 to that in 2012?
Make the answer very short. 0.72. What is the ratio of the % of adult population of Middle income in 2009 to that in 2013?
Your response must be concise. 0.63. What is the ratio of the % of adult population of Bolivia in 2009 to that in 2013?
Keep it short and to the point. 0.82. What is the ratio of the % of adult population of Tunisia in 2009 to that in 2013?
Make the answer very short. 0.69. What is the ratio of the % of adult population of Middle income in 2010 to that in 2011?
Your answer should be very brief. 0.89. What is the ratio of the % of adult population in Bolivia in 2010 to that in 2011?
Your answer should be very brief. 0.96. What is the ratio of the % of adult population in Tunisia in 2010 to that in 2011?
Make the answer very short. 0.84. What is the ratio of the % of adult population in Middle income in 2010 to that in 2012?
Provide a short and direct response. 0.81. What is the ratio of the % of adult population of Bolivia in 2010 to that in 2012?
Make the answer very short. 0.76. What is the ratio of the % of adult population of Tunisia in 2010 to that in 2012?
Your answer should be very brief. 0.82. What is the ratio of the % of adult population of Middle income in 2010 to that in 2013?
Make the answer very short. 0.73. What is the ratio of the % of adult population of Bolivia in 2010 to that in 2013?
Offer a very short reply. 0.8. What is the ratio of the % of adult population of Burundi in 2010 to that in 2013?
Give a very brief answer. 0.67. What is the ratio of the % of adult population of Tunisia in 2010 to that in 2013?
Give a very brief answer. 0.8. What is the ratio of the % of adult population of Middle income in 2011 to that in 2012?
Your answer should be very brief. 0.9. What is the ratio of the % of adult population of Bolivia in 2011 to that in 2012?
Make the answer very short. 0.8. What is the ratio of the % of adult population in Burundi in 2011 to that in 2012?
Your answer should be very brief. 1. What is the ratio of the % of adult population in Tunisia in 2011 to that in 2012?
Provide a succinct answer. 0.98. What is the ratio of the % of adult population in Middle income in 2011 to that in 2013?
Your answer should be compact. 0.82. What is the ratio of the % of adult population of Bolivia in 2011 to that in 2013?
Provide a short and direct response. 0.84. What is the ratio of the % of adult population of Tunisia in 2011 to that in 2013?
Provide a short and direct response. 0.95. What is the ratio of the % of adult population in Middle income in 2012 to that in 2013?
Offer a terse response. 0.9. What is the ratio of the % of adult population of Bolivia in 2012 to that in 2013?
Make the answer very short. 1.05. What is the ratio of the % of adult population of Burundi in 2012 to that in 2013?
Keep it short and to the point. 1. What is the ratio of the % of adult population of Tunisia in 2012 to that in 2013?
Your answer should be compact. 0.97. What is the difference between the highest and the second highest % of adult population in Middle income?
Provide a succinct answer. 1.14. What is the difference between the highest and the second highest % of adult population in Bolivia?
Offer a very short reply. 0.7. What is the difference between the highest and the lowest % of adult population of Middle income?
Your answer should be compact. 8.14. What is the difference between the highest and the lowest % of adult population in Bolivia?
Provide a succinct answer. 3.5. What is the difference between the highest and the lowest % of adult population of Tunisia?
Provide a succinct answer. 17.2. 